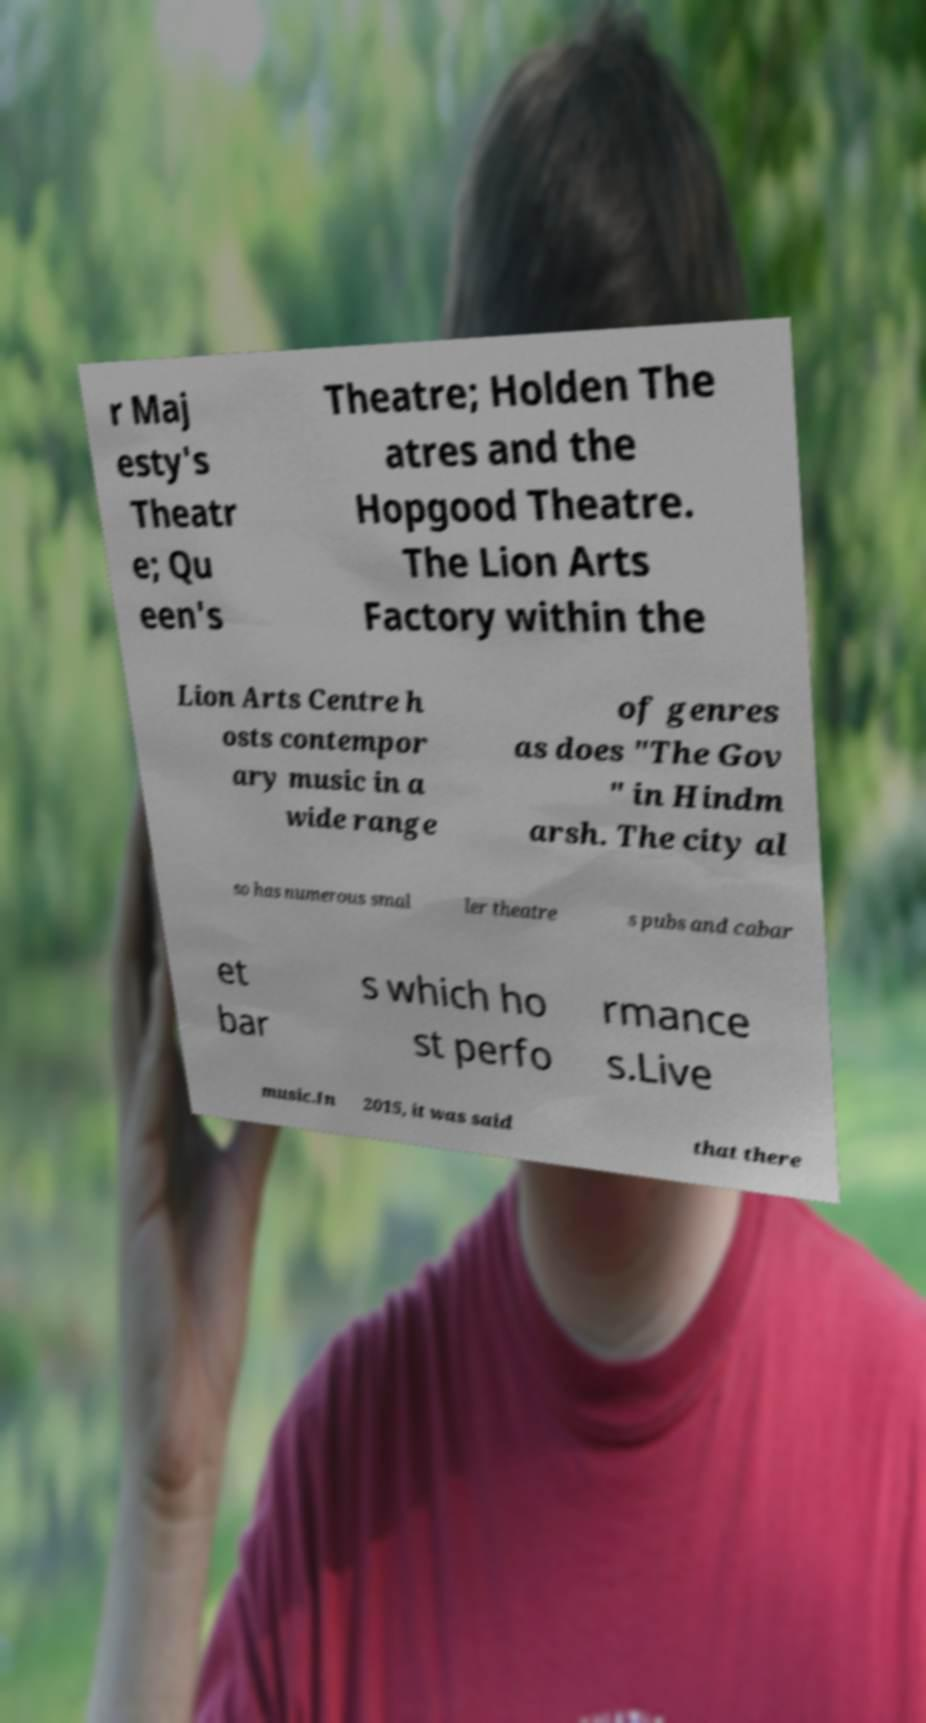Please read and relay the text visible in this image. What does it say? r Maj esty's Theatr e; Qu een's Theatre; Holden The atres and the Hopgood Theatre. The Lion Arts Factory within the Lion Arts Centre h osts contempor ary music in a wide range of genres as does "The Gov " in Hindm arsh. The city al so has numerous smal ler theatre s pubs and cabar et bar s which ho st perfo rmance s.Live music.In 2015, it was said that there 